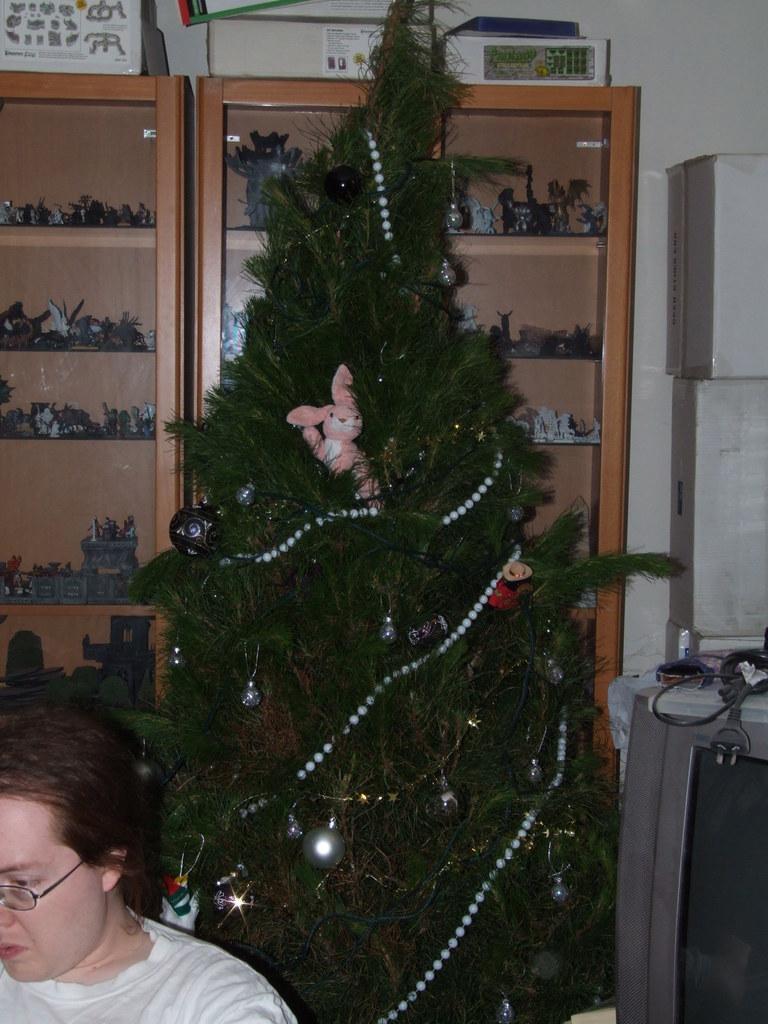Describe this image in one or two sentences. In the center of the image there is a christmas tree. On the right side of the image we can see television and boxes. In the background we can see toys placed in a shelves. At the bottom left corner there is a person. 